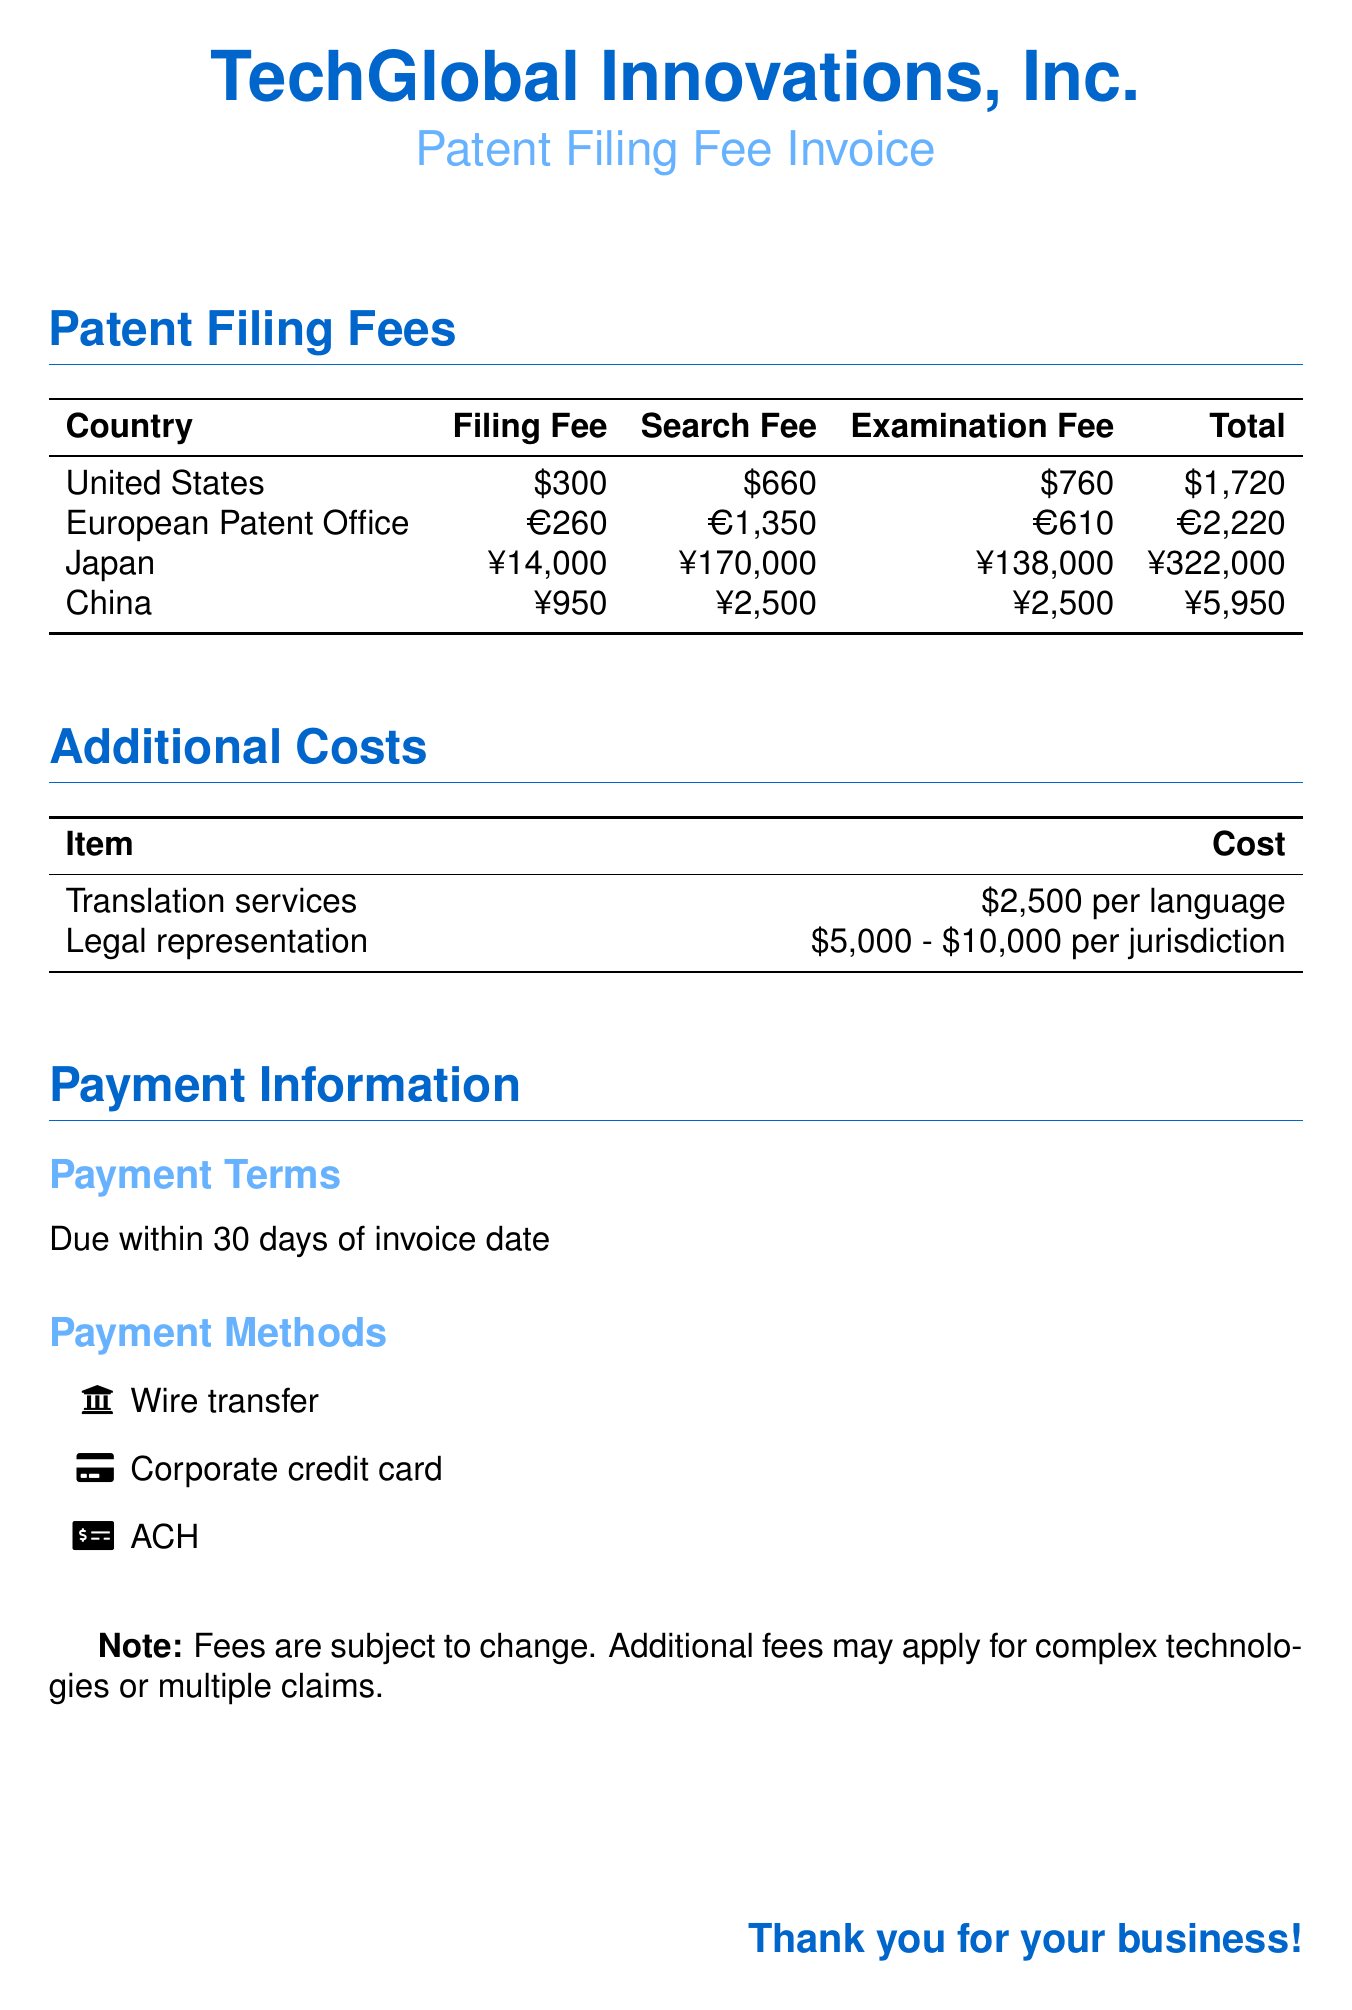what is the filing fee for the United States? The filing fee for the United States is listed in the table under the United States row.
Answer: $300 what is the total cost of patent filing in Japan? The total cost for Japan is calculated by adding the filing fee, search fee, and examination fee as detailed in the table.
Answer: ¥322,000 how much do translation services cost? The document specifies costs for translation services in the Additional Costs section.
Answer: $2,500 per language what is the examination fee for the European Patent Office? The examination fee for the European Patent Office can be found in the corresponding row in the table.
Answer: €610 what is the payment term mentioned in the document? The payment term is stated under the Payment Terms section.
Answer: Due within 30 days of invoice date what is the range for legal representation costs? The range for legal representation is listed in the Additional Costs section.
Answer: $5,000 - $10,000 per jurisdiction how much is the search fee for China? The search fee for China is indicated in the table along with other fees.
Answer: ¥2,500 which payment method is associated with a wire transfer? The payment method that allows for wire transfer is listed under Payment Methods.
Answer: Wire transfer what is the total fee for filing a patent in the European Patent Office? The total fee can be determined by adding the filing, search, and examination fees for the European Patent Office.
Answer: €2,220 